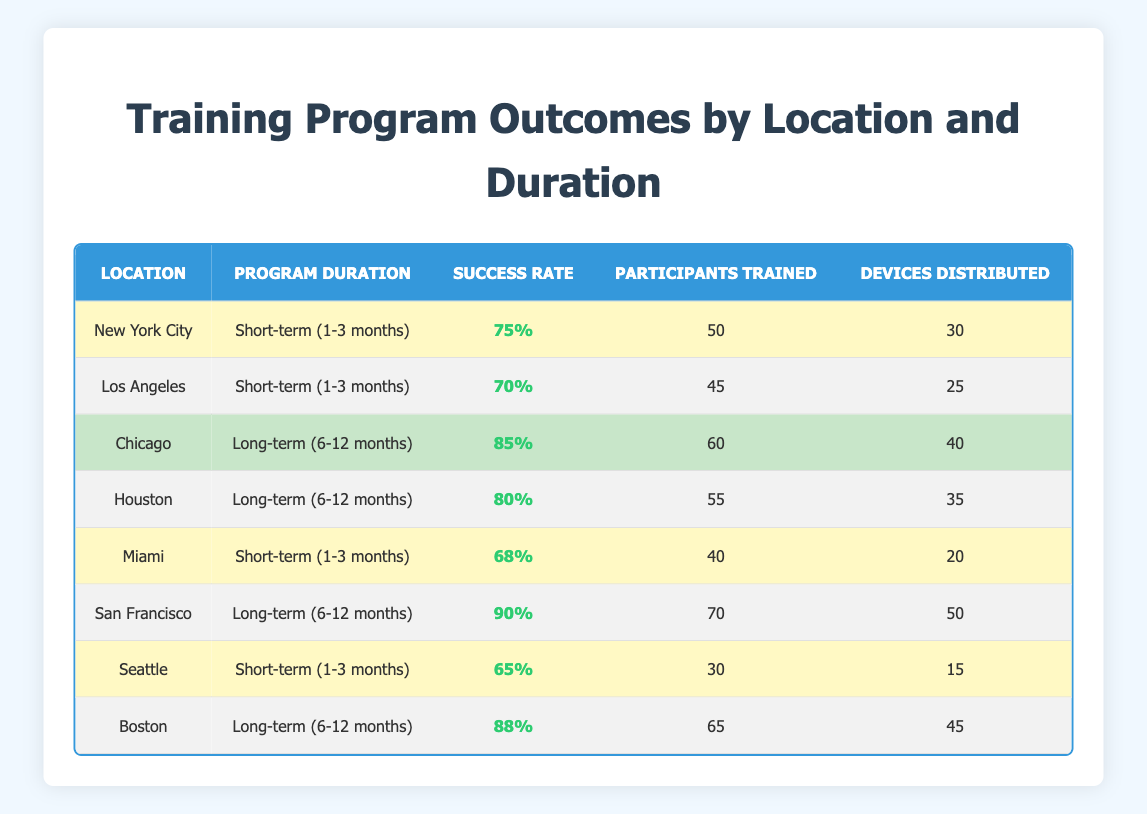What is the success rate of the training program in New York City? The success rate for New York City is explicitly listed in the table under the "Success Rate" column for that location, which is 75%.
Answer: 75% How many participants were trained in Los Angeles? The number of participants trained in Los Angeles can be found in the "Participants Trained" column for that location, which states 45.
Answer: 45 Which location had the highest success rate for long-term training programs? To determine the highest success rate for long-term training programs, we look at the "Success Rate" column for rows with "Long-term (6-12 months)" as their program duration. Chicago has a success rate of 85%, Houston 80%, San Francisco 90%, and Boston 88%. The highest is from San Francisco at 90%.
Answer: San Francisco What is the total number of devices distributed in short-term programs? To find the total devices distributed in short-term programs, we sum the "Devices Distributed" column for all rows under "Short-term (1-3 months)": 30 (NYC) + 25 (LA) + 20 (Miami) + 15 (Seattle) = 90.
Answer: 90 Did more participants get trained in Houston than in Miami? In the table, we can see that the number of participants trained in Houston is 55, while in Miami it is 40. Therefore, it's true that more participants were trained in Houston than in Miami.
Answer: Yes What is the average success rate of all training programs across all locations? To find the average success rate, we sum all success rates: 75 + 70 + 85 + 80 + 68 + 90 + 65 + 88 =  718. Then, we divide this by the number of programs (8): 718/8 = 89.75.
Answer: 89.75 Which was the least successful short-term program based on success rate? The success rates for short-term programs are: 75% (NYC), 70% (LA), 68% (Miami), and 65% (Seattle). The least successful program has a 65% success rate, which is Seattle.
Answer: Seattle How many more participants were trained in Chicago than in New York City? Participants trained in Chicago are 60, while in New York City, there are 50. We find the difference: 60 - 50 = 10.
Answer: 10 Which city distributed the most devices overall? Looking at the "Devices Distributed" column, the devices were distributed as follows: NYC 30, LA 25, Miami 20, Seattle 15, Chicago 40, Houston 35, San Francisco 50, Boston 45. Summing these gives: 30 + 25 + 20 + 15 + 40 + 35 + 50 + 45 =  250. San Francisco distributed the most devices at 50.
Answer: San Francisco 